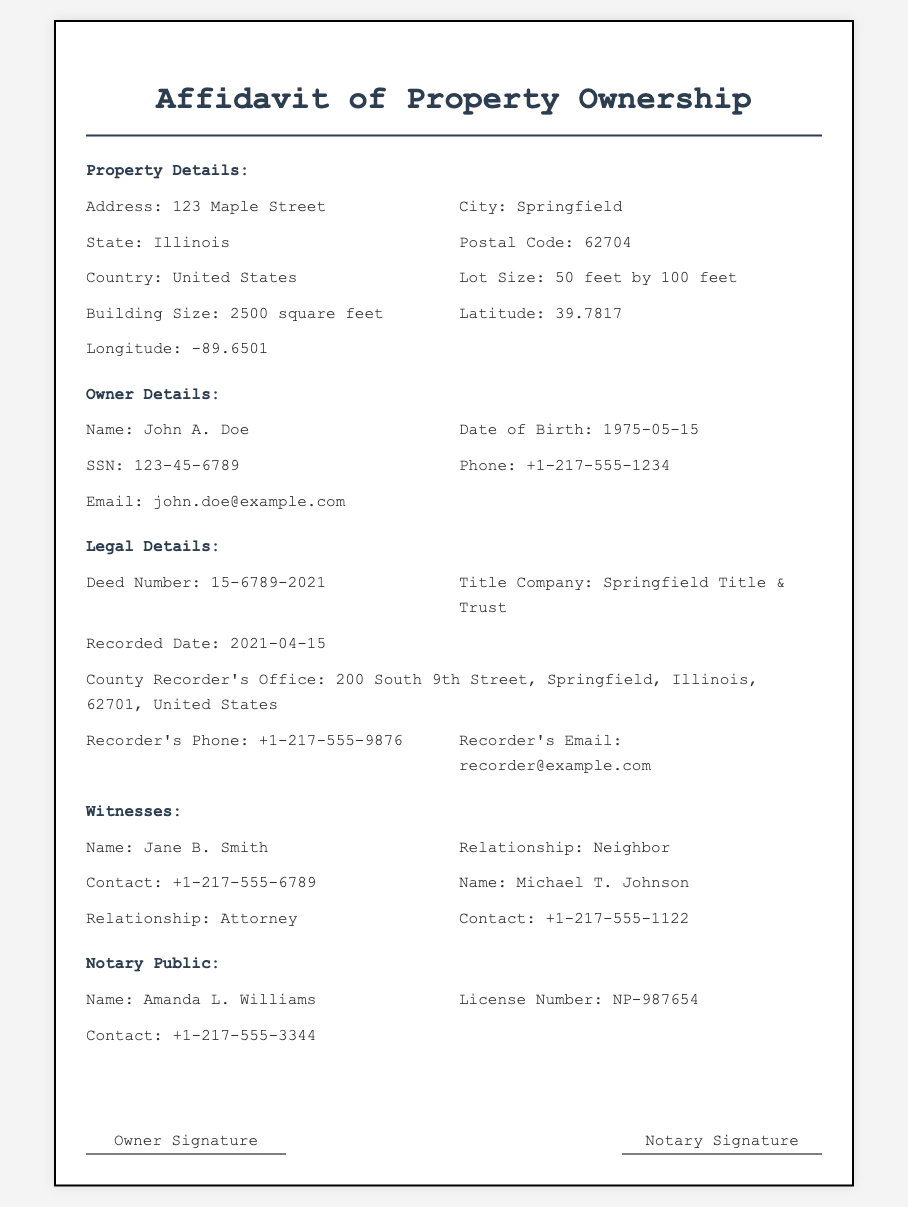What is the address of the property? The address of the property is specified in the document under Property Details.
Answer: 123 Maple Street Who is the legally recognized owner? The owner's name is found in the Owner Details section of the document.
Answer: John A. Doe What is the recorded date of the deed? The recorded date is found in the Legal Details section of the document.
Answer: 2021-04-15 What is the lot size of the property? The lot size is detailed in the Property Details section.
Answer: 50 feet by 100 feet What is the phone number of the County Recorder's Office? The phone number is provided in the Legal Details section.
Answer: +1-217-555-9876 Which title company is mentioned in the affidavit? The title company is listed in the Legal Details section of the document.
Answer: Springfield Title & Trust What is the license number of the Notary Public? This information is found in the Notary Public section of the document.
Answer: NP-987654 What relationship does Jane B. Smith have to the owner? This relationship is stated in the Witnesses section of the document.
Answer: Neighbor How large is the building on the property? The building size is noted in the Property Details section.
Answer: 2500 square feet 